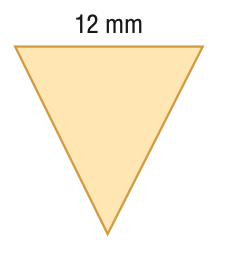Question: Find the area of the regular polygon. Round to the nearest tenth.
Choices:
A. 31.2
B. 62.4
C. 124.8
D. 144
Answer with the letter. Answer: B 